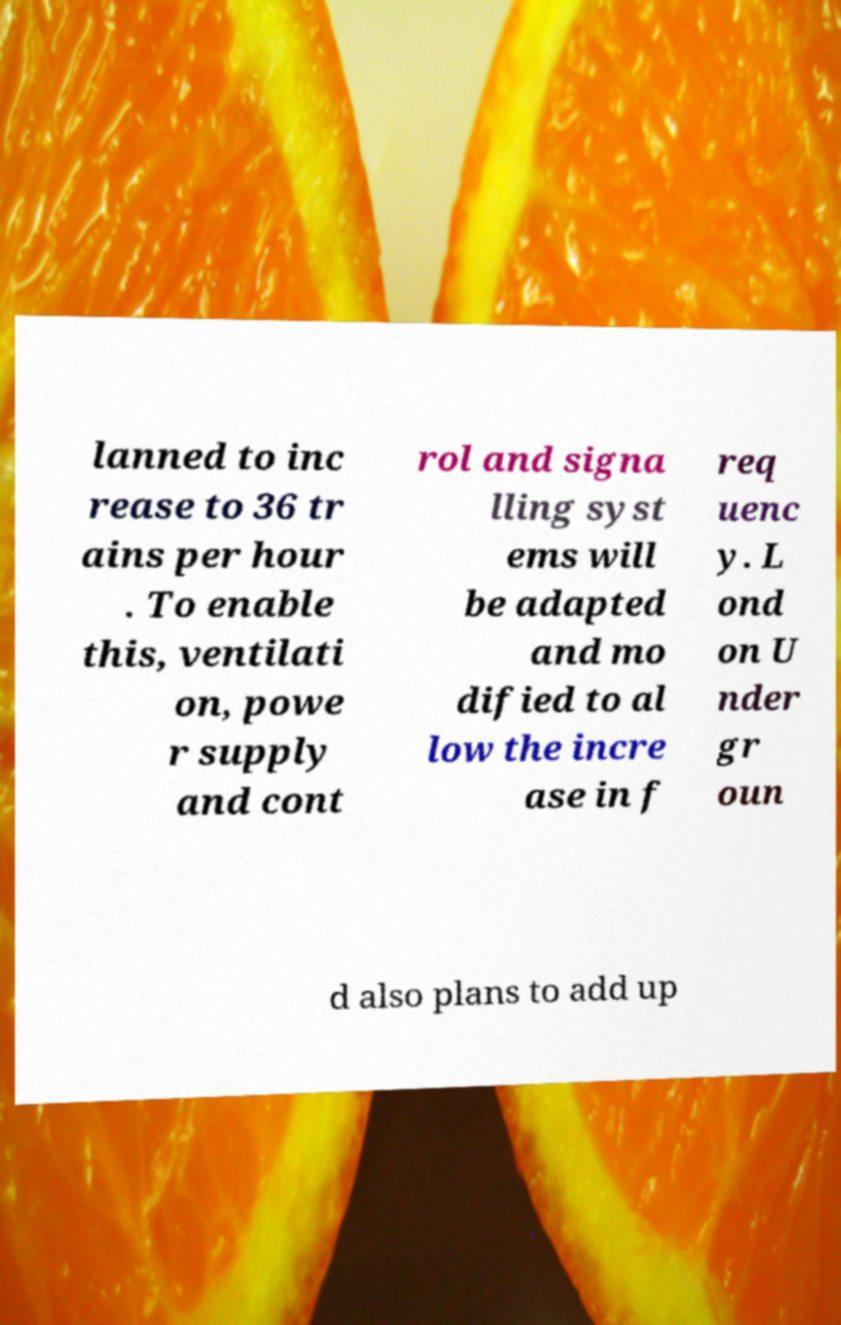Can you accurately transcribe the text from the provided image for me? lanned to inc rease to 36 tr ains per hour . To enable this, ventilati on, powe r supply and cont rol and signa lling syst ems will be adapted and mo dified to al low the incre ase in f req uenc y. L ond on U nder gr oun d also plans to add up 